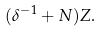Convert formula to latex. <formula><loc_0><loc_0><loc_500><loc_500>( \delta ^ { - 1 } + N ) Z .</formula> 